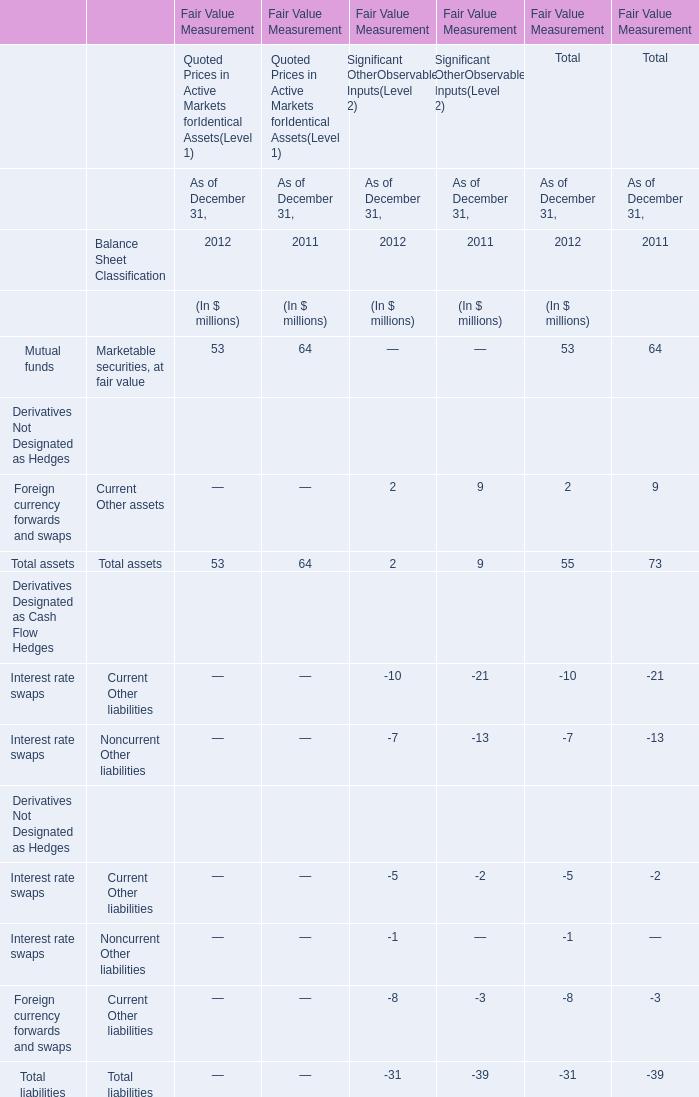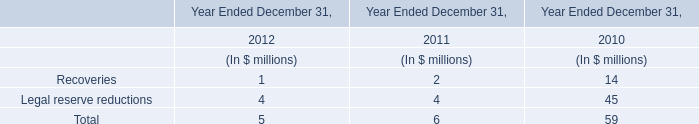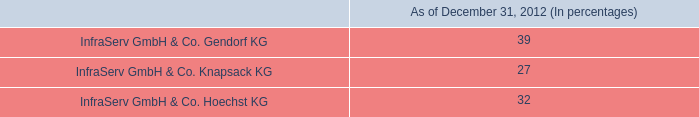What will Total liabilities reach in 2013 if it continues to grow at its current rate? (in million) 
Computations: (exp((1 + ((39 - 31) / 39)) * 2))
Answer: 56.64103. 